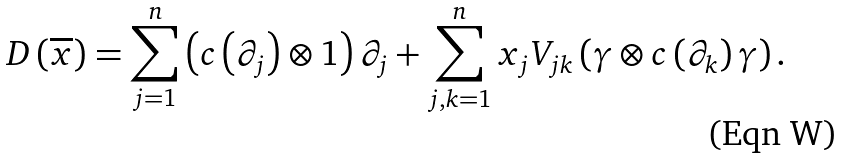<formula> <loc_0><loc_0><loc_500><loc_500>D \left ( \overline { x } \right ) = \sum _ { j = 1 } ^ { n } \left ( c \left ( \partial _ { j } \right ) \otimes 1 \right ) \partial _ { j } + \sum _ { j , k = 1 } ^ { n } x _ { j } V _ { j k } \left ( \gamma \otimes c \left ( \partial _ { k } \right ) \gamma \right ) .</formula> 